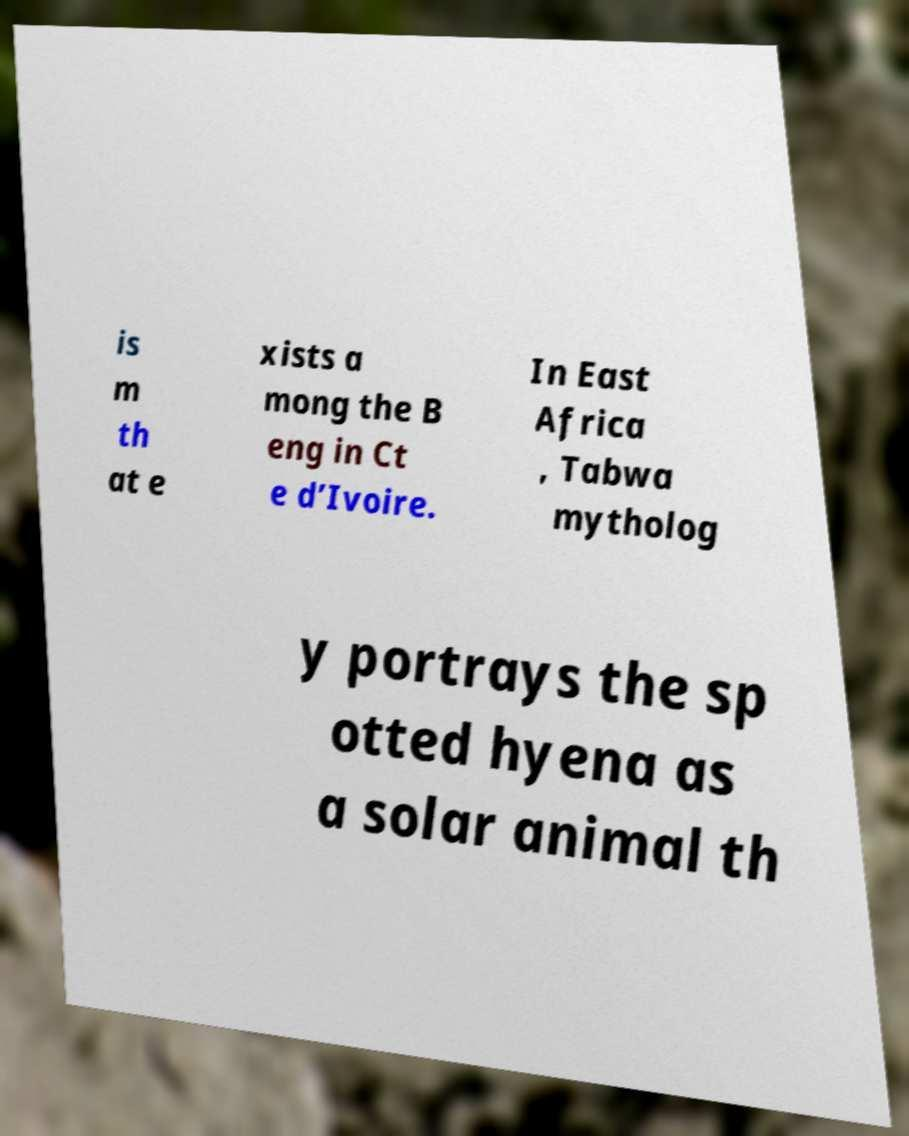There's text embedded in this image that I need extracted. Can you transcribe it verbatim? is m th at e xists a mong the B eng in Ct e d’Ivoire. In East Africa , Tabwa mytholog y portrays the sp otted hyena as a solar animal th 